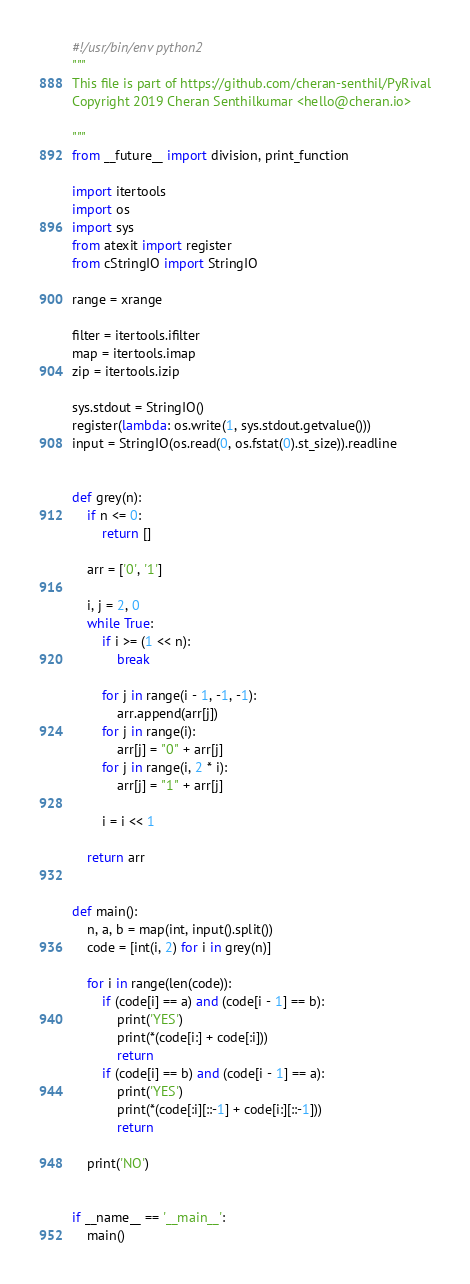Convert code to text. <code><loc_0><loc_0><loc_500><loc_500><_Python_>#!/usr/bin/env python2
"""
This file is part of https://github.com/cheran-senthil/PyRival
Copyright 2019 Cheran Senthilkumar <hello@cheran.io>

"""
from __future__ import division, print_function

import itertools
import os
import sys
from atexit import register
from cStringIO import StringIO

range = xrange

filter = itertools.ifilter
map = itertools.imap
zip = itertools.izip

sys.stdout = StringIO()
register(lambda: os.write(1, sys.stdout.getvalue()))
input = StringIO(os.read(0, os.fstat(0).st_size)).readline


def grey(n):
    if n <= 0:
        return []

    arr = ['0', '1']

    i, j = 2, 0
    while True:
        if i >= (1 << n):
            break

        for j in range(i - 1, -1, -1):
            arr.append(arr[j])
        for j in range(i):
            arr[j] = "0" + arr[j]
        for j in range(i, 2 * i):
            arr[j] = "1" + arr[j]

        i = i << 1

    return arr


def main():
    n, a, b = map(int, input().split())
    code = [int(i, 2) for i in grey(n)]

    for i in range(len(code)):
        if (code[i] == a) and (code[i - 1] == b):
            print('YES')
            print(*(code[i:] + code[:i]))
            return
        if (code[i] == b) and (code[i - 1] == a):
            print('YES')
            print(*(code[:i][::-1] + code[i:][::-1]))
            return

    print('NO')


if __name__ == '__main__':
    main()
</code> 